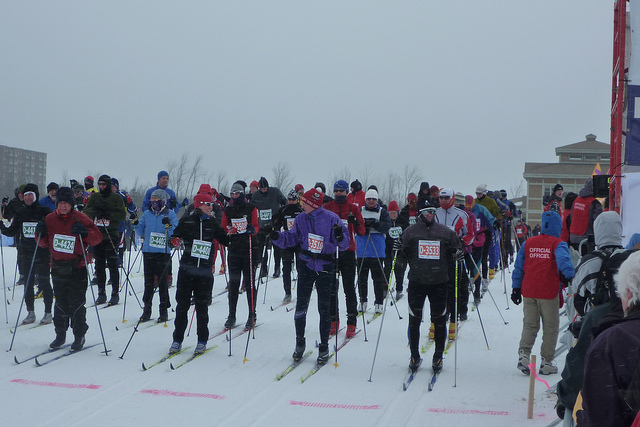Read and extract the text from this image. D 3510 D 3533 OFFICIAL 